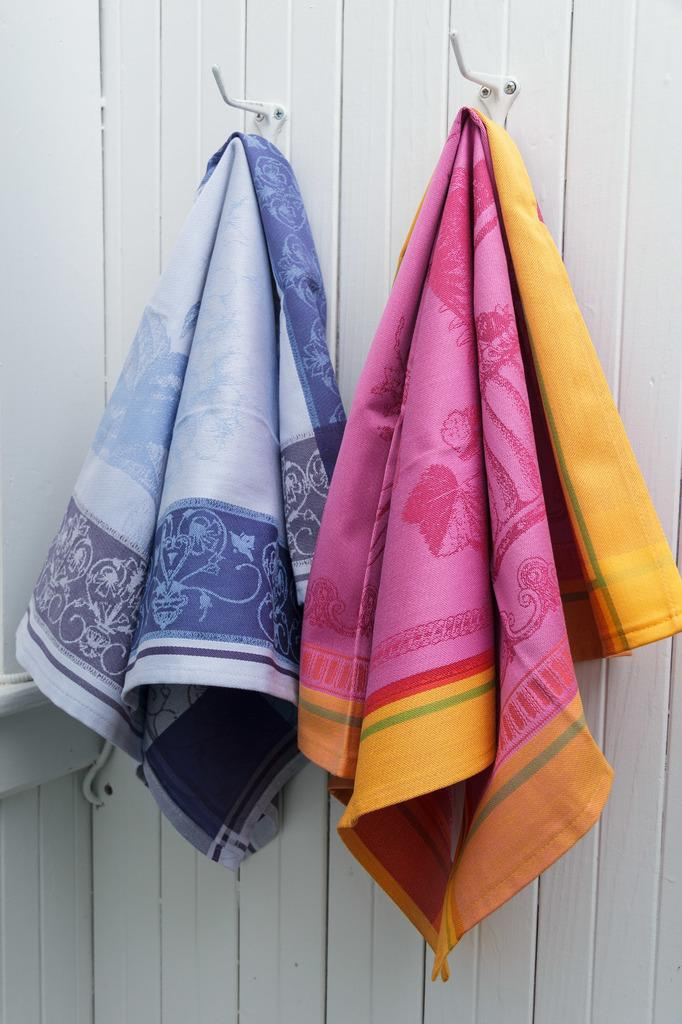What is hanging on the hooks in the image? There are clothes hanged on hooks in the image. What can be seen in the background of the image? There is a wall visible in the background of the image. How many wings are visible on the clothes in the image? There are no wings visible on the clothes in the image. What type of feast is being prepared in the image? There is no feast being prepared in the image. 